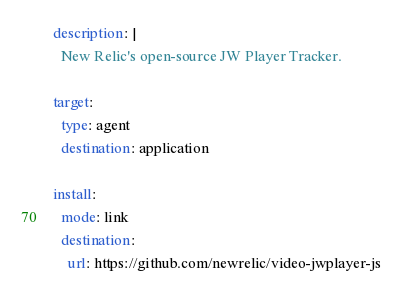<code> <loc_0><loc_0><loc_500><loc_500><_YAML_>description: |
  New Relic's open-source JW Player Tracker.

target:
  type: agent
  destination: application

install:
  mode: link
  destination:
    url: https://github.com/newrelic/video-jwplayer-js
</code> 